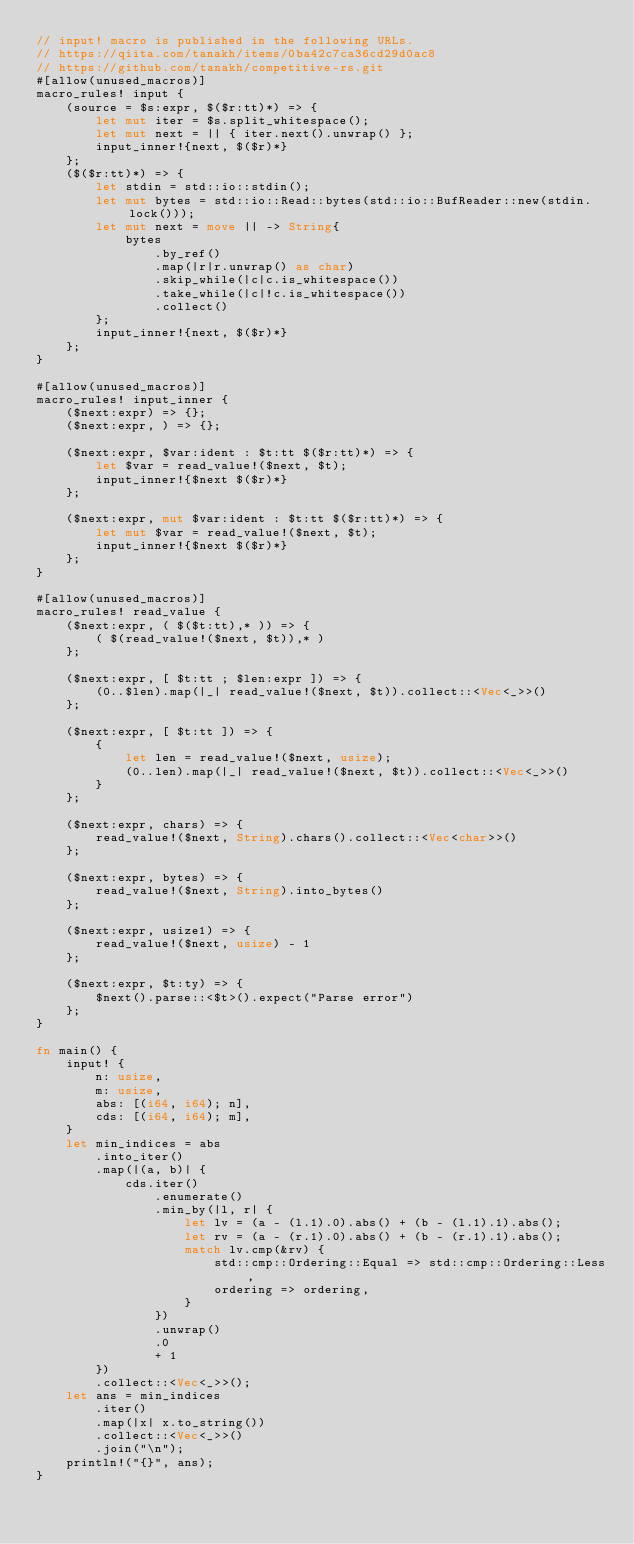Convert code to text. <code><loc_0><loc_0><loc_500><loc_500><_Rust_>// input! macro is published in the following URLs.
// https://qiita.com/tanakh/items/0ba42c7ca36cd29d0ac8
// https://github.com/tanakh/competitive-rs.git
#[allow(unused_macros)]
macro_rules! input {
    (source = $s:expr, $($r:tt)*) => {
        let mut iter = $s.split_whitespace();
        let mut next = || { iter.next().unwrap() };
        input_inner!{next, $($r)*}
    };
    ($($r:tt)*) => {
        let stdin = std::io::stdin();
        let mut bytes = std::io::Read::bytes(std::io::BufReader::new(stdin.lock()));
        let mut next = move || -> String{
            bytes
                .by_ref()
                .map(|r|r.unwrap() as char)
                .skip_while(|c|c.is_whitespace())
                .take_while(|c|!c.is_whitespace())
                .collect()
        };
        input_inner!{next, $($r)*}
    };
}

#[allow(unused_macros)]
macro_rules! input_inner {
    ($next:expr) => {};
    ($next:expr, ) => {};

    ($next:expr, $var:ident : $t:tt $($r:tt)*) => {
        let $var = read_value!($next, $t);
        input_inner!{$next $($r)*}
    };

    ($next:expr, mut $var:ident : $t:tt $($r:tt)*) => {
        let mut $var = read_value!($next, $t);
        input_inner!{$next $($r)*}
    };
}

#[allow(unused_macros)]
macro_rules! read_value {
    ($next:expr, ( $($t:tt),* )) => {
        ( $(read_value!($next, $t)),* )
    };

    ($next:expr, [ $t:tt ; $len:expr ]) => {
        (0..$len).map(|_| read_value!($next, $t)).collect::<Vec<_>>()
    };

    ($next:expr, [ $t:tt ]) => {
        {
            let len = read_value!($next, usize);
            (0..len).map(|_| read_value!($next, $t)).collect::<Vec<_>>()
        }
    };

    ($next:expr, chars) => {
        read_value!($next, String).chars().collect::<Vec<char>>()
    };

    ($next:expr, bytes) => {
        read_value!($next, String).into_bytes()
    };

    ($next:expr, usize1) => {
        read_value!($next, usize) - 1
    };

    ($next:expr, $t:ty) => {
        $next().parse::<$t>().expect("Parse error")
    };
}

fn main() {
    input! {
        n: usize,
        m: usize,
        abs: [(i64, i64); n],
        cds: [(i64, i64); m],
    }
    let min_indices = abs
        .into_iter()
        .map(|(a, b)| {
            cds.iter()
                .enumerate()
                .min_by(|l, r| {
                    let lv = (a - (l.1).0).abs() + (b - (l.1).1).abs();
                    let rv = (a - (r.1).0).abs() + (b - (r.1).1).abs();
                    match lv.cmp(&rv) {
                        std::cmp::Ordering::Equal => std::cmp::Ordering::Less,
                        ordering => ordering,
                    }
                })
                .unwrap()
                .0
                + 1
        })
        .collect::<Vec<_>>();
    let ans = min_indices
        .iter()
        .map(|x| x.to_string())
        .collect::<Vec<_>>()
        .join("\n");
    println!("{}", ans);
}
</code> 